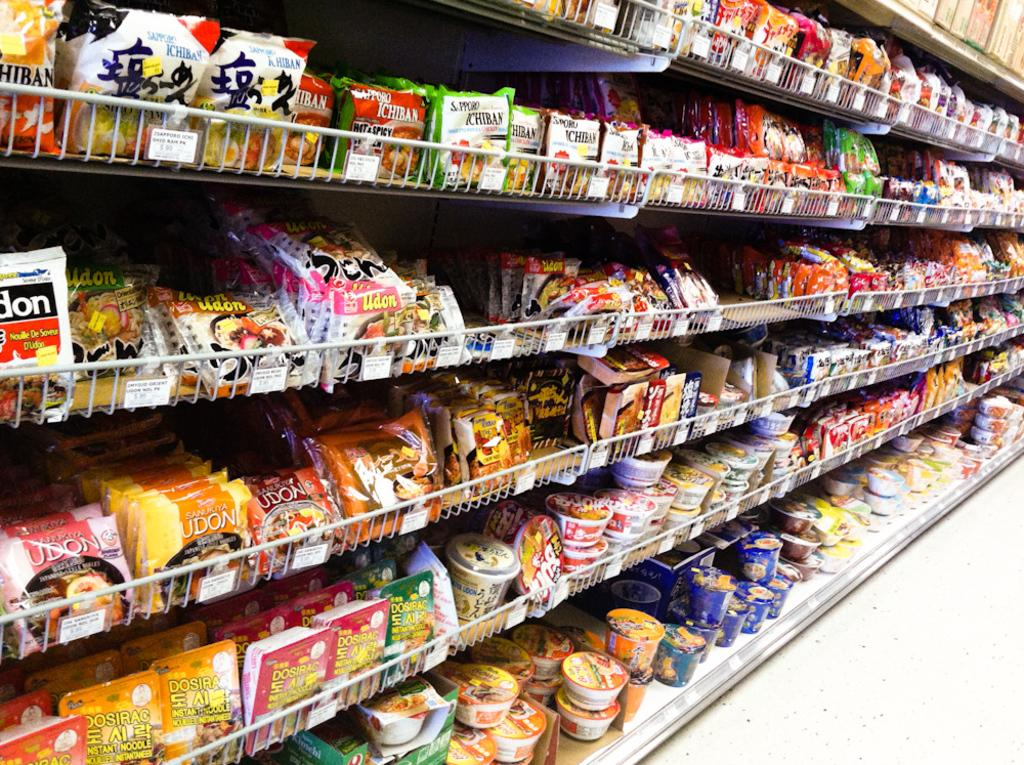<image>
Render a clear and concise summary of the photo. A row of ramen noodles showing brands such as Hiban 